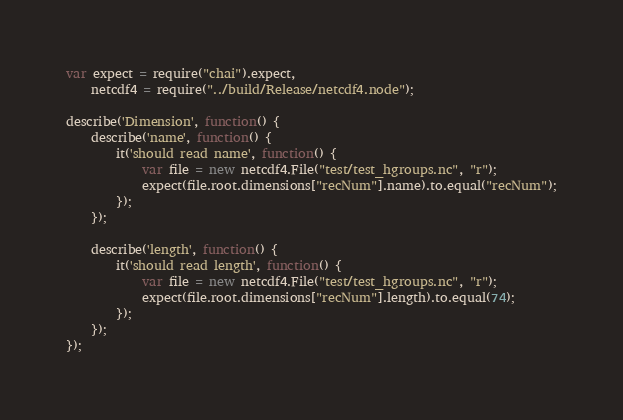Convert code to text. <code><loc_0><loc_0><loc_500><loc_500><_JavaScript_>var expect = require("chai").expect,
    netcdf4 = require("../build/Release/netcdf4.node");

describe('Dimension', function() {
    describe('name', function() {
        it('should read name', function() {
            var file = new netcdf4.File("test/test_hgroups.nc", "r");
            expect(file.root.dimensions["recNum"].name).to.equal("recNum");
        });
    });

    describe('length', function() {
        it('should read length', function() {
            var file = new netcdf4.File("test/test_hgroups.nc", "r");
            expect(file.root.dimensions["recNum"].length).to.equal(74);
        });
    });
});
</code> 